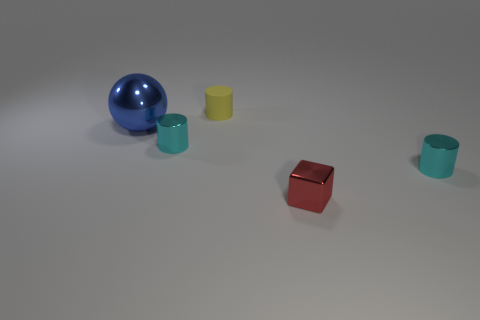There is a cube that is made of the same material as the large thing; what is its size? The cube appears to be comparably smaller than the large blue sphere. Specifically, it looks to be approximately one-third the diameter of the sphere if we consider size as a measure of linear dimensions such as height, width, or depth. 